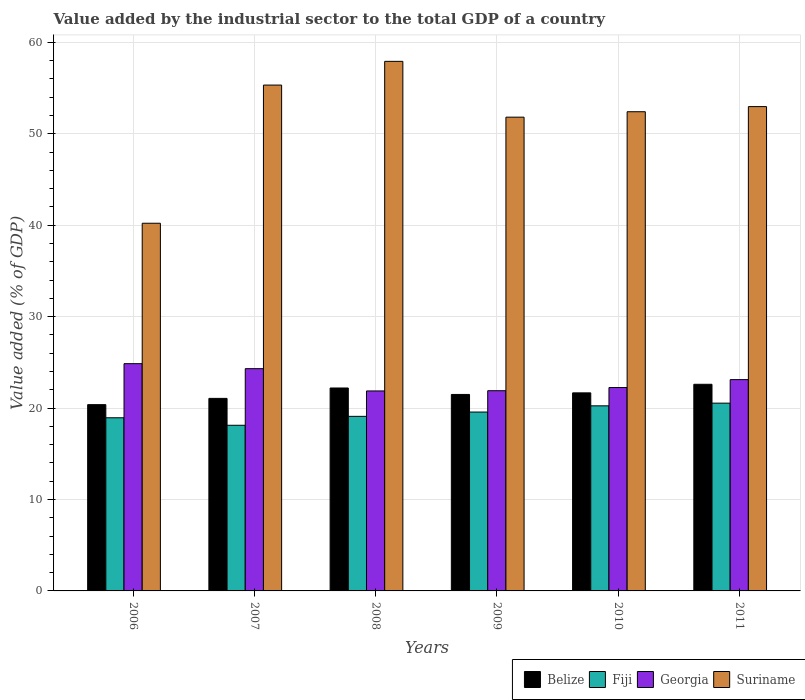How many different coloured bars are there?
Provide a short and direct response. 4. How many groups of bars are there?
Your answer should be compact. 6. Are the number of bars on each tick of the X-axis equal?
Provide a succinct answer. Yes. What is the label of the 6th group of bars from the left?
Provide a short and direct response. 2011. What is the value added by the industrial sector to the total GDP in Belize in 2010?
Provide a short and direct response. 21.66. Across all years, what is the maximum value added by the industrial sector to the total GDP in Georgia?
Provide a short and direct response. 24.86. Across all years, what is the minimum value added by the industrial sector to the total GDP in Belize?
Your answer should be compact. 20.37. In which year was the value added by the industrial sector to the total GDP in Georgia minimum?
Offer a terse response. 2008. What is the total value added by the industrial sector to the total GDP in Belize in the graph?
Provide a short and direct response. 129.38. What is the difference between the value added by the industrial sector to the total GDP in Belize in 2009 and that in 2011?
Provide a succinct answer. -1.11. What is the difference between the value added by the industrial sector to the total GDP in Belize in 2007 and the value added by the industrial sector to the total GDP in Fiji in 2006?
Provide a succinct answer. 2.12. What is the average value added by the industrial sector to the total GDP in Suriname per year?
Provide a short and direct response. 51.78. In the year 2008, what is the difference between the value added by the industrial sector to the total GDP in Suriname and value added by the industrial sector to the total GDP in Belize?
Offer a terse response. 35.72. What is the ratio of the value added by the industrial sector to the total GDP in Georgia in 2006 to that in 2009?
Provide a short and direct response. 1.14. Is the value added by the industrial sector to the total GDP in Belize in 2008 less than that in 2011?
Your answer should be very brief. Yes. What is the difference between the highest and the second highest value added by the industrial sector to the total GDP in Fiji?
Offer a very short reply. 0.29. What is the difference between the highest and the lowest value added by the industrial sector to the total GDP in Fiji?
Offer a very short reply. 2.42. In how many years, is the value added by the industrial sector to the total GDP in Georgia greater than the average value added by the industrial sector to the total GDP in Georgia taken over all years?
Ensure brevity in your answer.  3. What does the 1st bar from the left in 2010 represents?
Ensure brevity in your answer.  Belize. What does the 4th bar from the right in 2007 represents?
Provide a short and direct response. Belize. Is it the case that in every year, the sum of the value added by the industrial sector to the total GDP in Georgia and value added by the industrial sector to the total GDP in Fiji is greater than the value added by the industrial sector to the total GDP in Belize?
Offer a very short reply. Yes. Are all the bars in the graph horizontal?
Provide a succinct answer. No. What is the difference between two consecutive major ticks on the Y-axis?
Your response must be concise. 10. Are the values on the major ticks of Y-axis written in scientific E-notation?
Provide a short and direct response. No. Does the graph contain any zero values?
Provide a short and direct response. No. Does the graph contain grids?
Keep it short and to the point. Yes. Where does the legend appear in the graph?
Provide a succinct answer. Bottom right. How many legend labels are there?
Your answer should be very brief. 4. What is the title of the graph?
Provide a succinct answer. Value added by the industrial sector to the total GDP of a country. Does "Liechtenstein" appear as one of the legend labels in the graph?
Give a very brief answer. No. What is the label or title of the Y-axis?
Offer a terse response. Value added (% of GDP). What is the Value added (% of GDP) in Belize in 2006?
Provide a succinct answer. 20.37. What is the Value added (% of GDP) in Fiji in 2006?
Keep it short and to the point. 18.94. What is the Value added (% of GDP) in Georgia in 2006?
Provide a succinct answer. 24.86. What is the Value added (% of GDP) of Suriname in 2006?
Keep it short and to the point. 40.21. What is the Value added (% of GDP) of Belize in 2007?
Provide a succinct answer. 21.06. What is the Value added (% of GDP) in Fiji in 2007?
Give a very brief answer. 18.12. What is the Value added (% of GDP) of Georgia in 2007?
Offer a terse response. 24.31. What is the Value added (% of GDP) in Suriname in 2007?
Your response must be concise. 55.33. What is the Value added (% of GDP) in Belize in 2008?
Provide a succinct answer. 22.19. What is the Value added (% of GDP) in Fiji in 2008?
Offer a very short reply. 19.09. What is the Value added (% of GDP) in Georgia in 2008?
Make the answer very short. 21.87. What is the Value added (% of GDP) of Suriname in 2008?
Your response must be concise. 57.92. What is the Value added (% of GDP) in Belize in 2009?
Make the answer very short. 21.49. What is the Value added (% of GDP) in Fiji in 2009?
Provide a short and direct response. 19.56. What is the Value added (% of GDP) of Georgia in 2009?
Your answer should be compact. 21.9. What is the Value added (% of GDP) of Suriname in 2009?
Offer a terse response. 51.82. What is the Value added (% of GDP) of Belize in 2010?
Your answer should be compact. 21.66. What is the Value added (% of GDP) of Fiji in 2010?
Offer a terse response. 20.24. What is the Value added (% of GDP) in Georgia in 2010?
Give a very brief answer. 22.24. What is the Value added (% of GDP) in Suriname in 2010?
Make the answer very short. 52.41. What is the Value added (% of GDP) of Belize in 2011?
Provide a short and direct response. 22.6. What is the Value added (% of GDP) of Fiji in 2011?
Your answer should be compact. 20.54. What is the Value added (% of GDP) of Georgia in 2011?
Offer a very short reply. 23.11. What is the Value added (% of GDP) in Suriname in 2011?
Keep it short and to the point. 52.97. Across all years, what is the maximum Value added (% of GDP) in Belize?
Make the answer very short. 22.6. Across all years, what is the maximum Value added (% of GDP) in Fiji?
Offer a very short reply. 20.54. Across all years, what is the maximum Value added (% of GDP) in Georgia?
Your answer should be compact. 24.86. Across all years, what is the maximum Value added (% of GDP) of Suriname?
Make the answer very short. 57.92. Across all years, what is the minimum Value added (% of GDP) in Belize?
Provide a succinct answer. 20.37. Across all years, what is the minimum Value added (% of GDP) in Fiji?
Make the answer very short. 18.12. Across all years, what is the minimum Value added (% of GDP) of Georgia?
Your answer should be compact. 21.87. Across all years, what is the minimum Value added (% of GDP) in Suriname?
Ensure brevity in your answer.  40.21. What is the total Value added (% of GDP) in Belize in the graph?
Make the answer very short. 129.38. What is the total Value added (% of GDP) in Fiji in the graph?
Your answer should be very brief. 116.49. What is the total Value added (% of GDP) in Georgia in the graph?
Offer a terse response. 138.29. What is the total Value added (% of GDP) in Suriname in the graph?
Provide a short and direct response. 310.65. What is the difference between the Value added (% of GDP) in Belize in 2006 and that in 2007?
Offer a terse response. -0.69. What is the difference between the Value added (% of GDP) of Fiji in 2006 and that in 2007?
Keep it short and to the point. 0.82. What is the difference between the Value added (% of GDP) in Georgia in 2006 and that in 2007?
Provide a short and direct response. 0.55. What is the difference between the Value added (% of GDP) in Suriname in 2006 and that in 2007?
Provide a succinct answer. -15.11. What is the difference between the Value added (% of GDP) of Belize in 2006 and that in 2008?
Provide a short and direct response. -1.82. What is the difference between the Value added (% of GDP) in Fiji in 2006 and that in 2008?
Provide a short and direct response. -0.15. What is the difference between the Value added (% of GDP) in Georgia in 2006 and that in 2008?
Ensure brevity in your answer.  2.98. What is the difference between the Value added (% of GDP) in Suriname in 2006 and that in 2008?
Your response must be concise. -17.71. What is the difference between the Value added (% of GDP) in Belize in 2006 and that in 2009?
Your response must be concise. -1.12. What is the difference between the Value added (% of GDP) of Fiji in 2006 and that in 2009?
Offer a very short reply. -0.63. What is the difference between the Value added (% of GDP) of Georgia in 2006 and that in 2009?
Keep it short and to the point. 2.96. What is the difference between the Value added (% of GDP) of Suriname in 2006 and that in 2009?
Offer a very short reply. -11.6. What is the difference between the Value added (% of GDP) in Belize in 2006 and that in 2010?
Make the answer very short. -1.29. What is the difference between the Value added (% of GDP) of Fiji in 2006 and that in 2010?
Ensure brevity in your answer.  -1.31. What is the difference between the Value added (% of GDP) in Georgia in 2006 and that in 2010?
Provide a short and direct response. 2.61. What is the difference between the Value added (% of GDP) in Suriname in 2006 and that in 2010?
Provide a succinct answer. -12.2. What is the difference between the Value added (% of GDP) of Belize in 2006 and that in 2011?
Offer a terse response. -2.23. What is the difference between the Value added (% of GDP) of Fiji in 2006 and that in 2011?
Offer a terse response. -1.6. What is the difference between the Value added (% of GDP) in Georgia in 2006 and that in 2011?
Offer a very short reply. 1.75. What is the difference between the Value added (% of GDP) of Suriname in 2006 and that in 2011?
Your answer should be very brief. -12.76. What is the difference between the Value added (% of GDP) in Belize in 2007 and that in 2008?
Provide a succinct answer. -1.14. What is the difference between the Value added (% of GDP) in Fiji in 2007 and that in 2008?
Provide a succinct answer. -0.98. What is the difference between the Value added (% of GDP) of Georgia in 2007 and that in 2008?
Offer a terse response. 2.44. What is the difference between the Value added (% of GDP) of Suriname in 2007 and that in 2008?
Provide a succinct answer. -2.59. What is the difference between the Value added (% of GDP) of Belize in 2007 and that in 2009?
Offer a very short reply. -0.43. What is the difference between the Value added (% of GDP) in Fiji in 2007 and that in 2009?
Provide a short and direct response. -1.45. What is the difference between the Value added (% of GDP) in Georgia in 2007 and that in 2009?
Ensure brevity in your answer.  2.41. What is the difference between the Value added (% of GDP) of Suriname in 2007 and that in 2009?
Your answer should be very brief. 3.51. What is the difference between the Value added (% of GDP) in Belize in 2007 and that in 2010?
Ensure brevity in your answer.  -0.6. What is the difference between the Value added (% of GDP) of Fiji in 2007 and that in 2010?
Ensure brevity in your answer.  -2.13. What is the difference between the Value added (% of GDP) in Georgia in 2007 and that in 2010?
Your response must be concise. 2.07. What is the difference between the Value added (% of GDP) in Suriname in 2007 and that in 2010?
Your response must be concise. 2.92. What is the difference between the Value added (% of GDP) of Belize in 2007 and that in 2011?
Offer a terse response. -1.54. What is the difference between the Value added (% of GDP) in Fiji in 2007 and that in 2011?
Your response must be concise. -2.42. What is the difference between the Value added (% of GDP) in Georgia in 2007 and that in 2011?
Give a very brief answer. 1.2. What is the difference between the Value added (% of GDP) of Suriname in 2007 and that in 2011?
Your response must be concise. 2.36. What is the difference between the Value added (% of GDP) in Belize in 2008 and that in 2009?
Your response must be concise. 0.71. What is the difference between the Value added (% of GDP) in Fiji in 2008 and that in 2009?
Your response must be concise. -0.47. What is the difference between the Value added (% of GDP) of Georgia in 2008 and that in 2009?
Provide a succinct answer. -0.03. What is the difference between the Value added (% of GDP) of Suriname in 2008 and that in 2009?
Provide a succinct answer. 6.1. What is the difference between the Value added (% of GDP) in Belize in 2008 and that in 2010?
Give a very brief answer. 0.53. What is the difference between the Value added (% of GDP) of Fiji in 2008 and that in 2010?
Make the answer very short. -1.15. What is the difference between the Value added (% of GDP) of Georgia in 2008 and that in 2010?
Your response must be concise. -0.37. What is the difference between the Value added (% of GDP) in Suriname in 2008 and that in 2010?
Your answer should be compact. 5.51. What is the difference between the Value added (% of GDP) of Belize in 2008 and that in 2011?
Offer a terse response. -0.41. What is the difference between the Value added (% of GDP) of Fiji in 2008 and that in 2011?
Make the answer very short. -1.44. What is the difference between the Value added (% of GDP) in Georgia in 2008 and that in 2011?
Offer a terse response. -1.24. What is the difference between the Value added (% of GDP) in Suriname in 2008 and that in 2011?
Make the answer very short. 4.95. What is the difference between the Value added (% of GDP) in Belize in 2009 and that in 2010?
Your response must be concise. -0.17. What is the difference between the Value added (% of GDP) in Fiji in 2009 and that in 2010?
Offer a very short reply. -0.68. What is the difference between the Value added (% of GDP) in Georgia in 2009 and that in 2010?
Keep it short and to the point. -0.35. What is the difference between the Value added (% of GDP) of Suriname in 2009 and that in 2010?
Provide a short and direct response. -0.59. What is the difference between the Value added (% of GDP) of Belize in 2009 and that in 2011?
Your response must be concise. -1.11. What is the difference between the Value added (% of GDP) in Fiji in 2009 and that in 2011?
Make the answer very short. -0.97. What is the difference between the Value added (% of GDP) in Georgia in 2009 and that in 2011?
Ensure brevity in your answer.  -1.21. What is the difference between the Value added (% of GDP) in Suriname in 2009 and that in 2011?
Ensure brevity in your answer.  -1.15. What is the difference between the Value added (% of GDP) in Belize in 2010 and that in 2011?
Make the answer very short. -0.94. What is the difference between the Value added (% of GDP) of Fiji in 2010 and that in 2011?
Provide a short and direct response. -0.29. What is the difference between the Value added (% of GDP) of Georgia in 2010 and that in 2011?
Give a very brief answer. -0.87. What is the difference between the Value added (% of GDP) in Suriname in 2010 and that in 2011?
Your answer should be very brief. -0.56. What is the difference between the Value added (% of GDP) in Belize in 2006 and the Value added (% of GDP) in Fiji in 2007?
Your response must be concise. 2.26. What is the difference between the Value added (% of GDP) of Belize in 2006 and the Value added (% of GDP) of Georgia in 2007?
Give a very brief answer. -3.94. What is the difference between the Value added (% of GDP) in Belize in 2006 and the Value added (% of GDP) in Suriname in 2007?
Your response must be concise. -34.95. What is the difference between the Value added (% of GDP) in Fiji in 2006 and the Value added (% of GDP) in Georgia in 2007?
Provide a short and direct response. -5.37. What is the difference between the Value added (% of GDP) of Fiji in 2006 and the Value added (% of GDP) of Suriname in 2007?
Offer a terse response. -36.39. What is the difference between the Value added (% of GDP) of Georgia in 2006 and the Value added (% of GDP) of Suriname in 2007?
Your response must be concise. -30.47. What is the difference between the Value added (% of GDP) in Belize in 2006 and the Value added (% of GDP) in Fiji in 2008?
Provide a succinct answer. 1.28. What is the difference between the Value added (% of GDP) in Belize in 2006 and the Value added (% of GDP) in Georgia in 2008?
Your answer should be compact. -1.5. What is the difference between the Value added (% of GDP) of Belize in 2006 and the Value added (% of GDP) of Suriname in 2008?
Give a very brief answer. -37.55. What is the difference between the Value added (% of GDP) in Fiji in 2006 and the Value added (% of GDP) in Georgia in 2008?
Your answer should be compact. -2.93. What is the difference between the Value added (% of GDP) in Fiji in 2006 and the Value added (% of GDP) in Suriname in 2008?
Make the answer very short. -38.98. What is the difference between the Value added (% of GDP) in Georgia in 2006 and the Value added (% of GDP) in Suriname in 2008?
Give a very brief answer. -33.06. What is the difference between the Value added (% of GDP) of Belize in 2006 and the Value added (% of GDP) of Fiji in 2009?
Keep it short and to the point. 0.81. What is the difference between the Value added (% of GDP) in Belize in 2006 and the Value added (% of GDP) in Georgia in 2009?
Offer a very short reply. -1.52. What is the difference between the Value added (% of GDP) in Belize in 2006 and the Value added (% of GDP) in Suriname in 2009?
Your answer should be very brief. -31.44. What is the difference between the Value added (% of GDP) of Fiji in 2006 and the Value added (% of GDP) of Georgia in 2009?
Your answer should be very brief. -2.96. What is the difference between the Value added (% of GDP) in Fiji in 2006 and the Value added (% of GDP) in Suriname in 2009?
Give a very brief answer. -32.88. What is the difference between the Value added (% of GDP) in Georgia in 2006 and the Value added (% of GDP) in Suriname in 2009?
Your response must be concise. -26.96. What is the difference between the Value added (% of GDP) in Belize in 2006 and the Value added (% of GDP) in Fiji in 2010?
Your answer should be compact. 0.13. What is the difference between the Value added (% of GDP) of Belize in 2006 and the Value added (% of GDP) of Georgia in 2010?
Your answer should be very brief. -1.87. What is the difference between the Value added (% of GDP) in Belize in 2006 and the Value added (% of GDP) in Suriname in 2010?
Provide a short and direct response. -32.04. What is the difference between the Value added (% of GDP) in Fiji in 2006 and the Value added (% of GDP) in Georgia in 2010?
Provide a succinct answer. -3.3. What is the difference between the Value added (% of GDP) of Fiji in 2006 and the Value added (% of GDP) of Suriname in 2010?
Make the answer very short. -33.47. What is the difference between the Value added (% of GDP) of Georgia in 2006 and the Value added (% of GDP) of Suriname in 2010?
Your answer should be compact. -27.55. What is the difference between the Value added (% of GDP) of Belize in 2006 and the Value added (% of GDP) of Fiji in 2011?
Ensure brevity in your answer.  -0.16. What is the difference between the Value added (% of GDP) in Belize in 2006 and the Value added (% of GDP) in Georgia in 2011?
Give a very brief answer. -2.74. What is the difference between the Value added (% of GDP) in Belize in 2006 and the Value added (% of GDP) in Suriname in 2011?
Your answer should be compact. -32.6. What is the difference between the Value added (% of GDP) in Fiji in 2006 and the Value added (% of GDP) in Georgia in 2011?
Your answer should be very brief. -4.17. What is the difference between the Value added (% of GDP) in Fiji in 2006 and the Value added (% of GDP) in Suriname in 2011?
Give a very brief answer. -34.03. What is the difference between the Value added (% of GDP) in Georgia in 2006 and the Value added (% of GDP) in Suriname in 2011?
Provide a short and direct response. -28.11. What is the difference between the Value added (% of GDP) of Belize in 2007 and the Value added (% of GDP) of Fiji in 2008?
Offer a very short reply. 1.97. What is the difference between the Value added (% of GDP) in Belize in 2007 and the Value added (% of GDP) in Georgia in 2008?
Make the answer very short. -0.81. What is the difference between the Value added (% of GDP) in Belize in 2007 and the Value added (% of GDP) in Suriname in 2008?
Your answer should be compact. -36.86. What is the difference between the Value added (% of GDP) in Fiji in 2007 and the Value added (% of GDP) in Georgia in 2008?
Your answer should be compact. -3.75. What is the difference between the Value added (% of GDP) of Fiji in 2007 and the Value added (% of GDP) of Suriname in 2008?
Offer a terse response. -39.8. What is the difference between the Value added (% of GDP) in Georgia in 2007 and the Value added (% of GDP) in Suriname in 2008?
Ensure brevity in your answer.  -33.61. What is the difference between the Value added (% of GDP) in Belize in 2007 and the Value added (% of GDP) in Fiji in 2009?
Give a very brief answer. 1.5. What is the difference between the Value added (% of GDP) in Belize in 2007 and the Value added (% of GDP) in Georgia in 2009?
Your answer should be very brief. -0.84. What is the difference between the Value added (% of GDP) in Belize in 2007 and the Value added (% of GDP) in Suriname in 2009?
Offer a very short reply. -30.76. What is the difference between the Value added (% of GDP) in Fiji in 2007 and the Value added (% of GDP) in Georgia in 2009?
Provide a succinct answer. -3.78. What is the difference between the Value added (% of GDP) in Fiji in 2007 and the Value added (% of GDP) in Suriname in 2009?
Make the answer very short. -33.7. What is the difference between the Value added (% of GDP) of Georgia in 2007 and the Value added (% of GDP) of Suriname in 2009?
Offer a very short reply. -27.51. What is the difference between the Value added (% of GDP) of Belize in 2007 and the Value added (% of GDP) of Fiji in 2010?
Provide a short and direct response. 0.82. What is the difference between the Value added (% of GDP) in Belize in 2007 and the Value added (% of GDP) in Georgia in 2010?
Make the answer very short. -1.18. What is the difference between the Value added (% of GDP) in Belize in 2007 and the Value added (% of GDP) in Suriname in 2010?
Your response must be concise. -31.35. What is the difference between the Value added (% of GDP) of Fiji in 2007 and the Value added (% of GDP) of Georgia in 2010?
Your answer should be compact. -4.13. What is the difference between the Value added (% of GDP) of Fiji in 2007 and the Value added (% of GDP) of Suriname in 2010?
Make the answer very short. -34.29. What is the difference between the Value added (% of GDP) in Georgia in 2007 and the Value added (% of GDP) in Suriname in 2010?
Offer a very short reply. -28.1. What is the difference between the Value added (% of GDP) of Belize in 2007 and the Value added (% of GDP) of Fiji in 2011?
Offer a terse response. 0.52. What is the difference between the Value added (% of GDP) of Belize in 2007 and the Value added (% of GDP) of Georgia in 2011?
Make the answer very short. -2.05. What is the difference between the Value added (% of GDP) in Belize in 2007 and the Value added (% of GDP) in Suriname in 2011?
Make the answer very short. -31.91. What is the difference between the Value added (% of GDP) of Fiji in 2007 and the Value added (% of GDP) of Georgia in 2011?
Make the answer very short. -4.99. What is the difference between the Value added (% of GDP) in Fiji in 2007 and the Value added (% of GDP) in Suriname in 2011?
Your response must be concise. -34.85. What is the difference between the Value added (% of GDP) of Georgia in 2007 and the Value added (% of GDP) of Suriname in 2011?
Your response must be concise. -28.66. What is the difference between the Value added (% of GDP) in Belize in 2008 and the Value added (% of GDP) in Fiji in 2009?
Your answer should be very brief. 2.63. What is the difference between the Value added (% of GDP) of Belize in 2008 and the Value added (% of GDP) of Georgia in 2009?
Your response must be concise. 0.3. What is the difference between the Value added (% of GDP) in Belize in 2008 and the Value added (% of GDP) in Suriname in 2009?
Give a very brief answer. -29.62. What is the difference between the Value added (% of GDP) in Fiji in 2008 and the Value added (% of GDP) in Georgia in 2009?
Your answer should be compact. -2.8. What is the difference between the Value added (% of GDP) in Fiji in 2008 and the Value added (% of GDP) in Suriname in 2009?
Your response must be concise. -32.72. What is the difference between the Value added (% of GDP) in Georgia in 2008 and the Value added (% of GDP) in Suriname in 2009?
Your response must be concise. -29.94. What is the difference between the Value added (% of GDP) of Belize in 2008 and the Value added (% of GDP) of Fiji in 2010?
Your answer should be compact. 1.95. What is the difference between the Value added (% of GDP) of Belize in 2008 and the Value added (% of GDP) of Georgia in 2010?
Your answer should be compact. -0.05. What is the difference between the Value added (% of GDP) of Belize in 2008 and the Value added (% of GDP) of Suriname in 2010?
Keep it short and to the point. -30.22. What is the difference between the Value added (% of GDP) of Fiji in 2008 and the Value added (% of GDP) of Georgia in 2010?
Offer a very short reply. -3.15. What is the difference between the Value added (% of GDP) of Fiji in 2008 and the Value added (% of GDP) of Suriname in 2010?
Your response must be concise. -33.32. What is the difference between the Value added (% of GDP) of Georgia in 2008 and the Value added (% of GDP) of Suriname in 2010?
Give a very brief answer. -30.54. What is the difference between the Value added (% of GDP) in Belize in 2008 and the Value added (% of GDP) in Fiji in 2011?
Keep it short and to the point. 1.66. What is the difference between the Value added (% of GDP) in Belize in 2008 and the Value added (% of GDP) in Georgia in 2011?
Offer a terse response. -0.92. What is the difference between the Value added (% of GDP) of Belize in 2008 and the Value added (% of GDP) of Suriname in 2011?
Offer a terse response. -30.78. What is the difference between the Value added (% of GDP) of Fiji in 2008 and the Value added (% of GDP) of Georgia in 2011?
Your answer should be compact. -4.02. What is the difference between the Value added (% of GDP) of Fiji in 2008 and the Value added (% of GDP) of Suriname in 2011?
Provide a succinct answer. -33.88. What is the difference between the Value added (% of GDP) in Georgia in 2008 and the Value added (% of GDP) in Suriname in 2011?
Your response must be concise. -31.1. What is the difference between the Value added (% of GDP) in Belize in 2009 and the Value added (% of GDP) in Fiji in 2010?
Keep it short and to the point. 1.25. What is the difference between the Value added (% of GDP) in Belize in 2009 and the Value added (% of GDP) in Georgia in 2010?
Keep it short and to the point. -0.75. What is the difference between the Value added (% of GDP) of Belize in 2009 and the Value added (% of GDP) of Suriname in 2010?
Keep it short and to the point. -30.92. What is the difference between the Value added (% of GDP) of Fiji in 2009 and the Value added (% of GDP) of Georgia in 2010?
Offer a very short reply. -2.68. What is the difference between the Value added (% of GDP) of Fiji in 2009 and the Value added (% of GDP) of Suriname in 2010?
Provide a short and direct response. -32.85. What is the difference between the Value added (% of GDP) of Georgia in 2009 and the Value added (% of GDP) of Suriname in 2010?
Provide a succinct answer. -30.51. What is the difference between the Value added (% of GDP) in Belize in 2009 and the Value added (% of GDP) in Fiji in 2011?
Provide a succinct answer. 0.95. What is the difference between the Value added (% of GDP) of Belize in 2009 and the Value added (% of GDP) of Georgia in 2011?
Provide a short and direct response. -1.62. What is the difference between the Value added (% of GDP) of Belize in 2009 and the Value added (% of GDP) of Suriname in 2011?
Provide a short and direct response. -31.48. What is the difference between the Value added (% of GDP) of Fiji in 2009 and the Value added (% of GDP) of Georgia in 2011?
Provide a short and direct response. -3.55. What is the difference between the Value added (% of GDP) in Fiji in 2009 and the Value added (% of GDP) in Suriname in 2011?
Make the answer very short. -33.41. What is the difference between the Value added (% of GDP) of Georgia in 2009 and the Value added (% of GDP) of Suriname in 2011?
Your answer should be compact. -31.07. What is the difference between the Value added (% of GDP) of Belize in 2010 and the Value added (% of GDP) of Fiji in 2011?
Provide a succinct answer. 1.12. What is the difference between the Value added (% of GDP) of Belize in 2010 and the Value added (% of GDP) of Georgia in 2011?
Your response must be concise. -1.45. What is the difference between the Value added (% of GDP) of Belize in 2010 and the Value added (% of GDP) of Suriname in 2011?
Your answer should be compact. -31.31. What is the difference between the Value added (% of GDP) of Fiji in 2010 and the Value added (% of GDP) of Georgia in 2011?
Your answer should be very brief. -2.87. What is the difference between the Value added (% of GDP) in Fiji in 2010 and the Value added (% of GDP) in Suriname in 2011?
Make the answer very short. -32.73. What is the difference between the Value added (% of GDP) in Georgia in 2010 and the Value added (% of GDP) in Suriname in 2011?
Your response must be concise. -30.73. What is the average Value added (% of GDP) in Belize per year?
Offer a very short reply. 21.56. What is the average Value added (% of GDP) of Fiji per year?
Offer a very short reply. 19.42. What is the average Value added (% of GDP) of Georgia per year?
Give a very brief answer. 23.05. What is the average Value added (% of GDP) of Suriname per year?
Your answer should be very brief. 51.78. In the year 2006, what is the difference between the Value added (% of GDP) in Belize and Value added (% of GDP) in Fiji?
Provide a succinct answer. 1.44. In the year 2006, what is the difference between the Value added (% of GDP) of Belize and Value added (% of GDP) of Georgia?
Your answer should be compact. -4.48. In the year 2006, what is the difference between the Value added (% of GDP) in Belize and Value added (% of GDP) in Suriname?
Keep it short and to the point. -19.84. In the year 2006, what is the difference between the Value added (% of GDP) of Fiji and Value added (% of GDP) of Georgia?
Provide a short and direct response. -5.92. In the year 2006, what is the difference between the Value added (% of GDP) of Fiji and Value added (% of GDP) of Suriname?
Keep it short and to the point. -21.28. In the year 2006, what is the difference between the Value added (% of GDP) of Georgia and Value added (% of GDP) of Suriname?
Your answer should be compact. -15.36. In the year 2007, what is the difference between the Value added (% of GDP) in Belize and Value added (% of GDP) in Fiji?
Provide a succinct answer. 2.94. In the year 2007, what is the difference between the Value added (% of GDP) in Belize and Value added (% of GDP) in Georgia?
Offer a very short reply. -3.25. In the year 2007, what is the difference between the Value added (% of GDP) in Belize and Value added (% of GDP) in Suriname?
Ensure brevity in your answer.  -34.27. In the year 2007, what is the difference between the Value added (% of GDP) of Fiji and Value added (% of GDP) of Georgia?
Provide a short and direct response. -6.19. In the year 2007, what is the difference between the Value added (% of GDP) in Fiji and Value added (% of GDP) in Suriname?
Keep it short and to the point. -37.21. In the year 2007, what is the difference between the Value added (% of GDP) in Georgia and Value added (% of GDP) in Suriname?
Provide a succinct answer. -31.02. In the year 2008, what is the difference between the Value added (% of GDP) in Belize and Value added (% of GDP) in Fiji?
Provide a succinct answer. 3.1. In the year 2008, what is the difference between the Value added (% of GDP) of Belize and Value added (% of GDP) of Georgia?
Ensure brevity in your answer.  0.32. In the year 2008, what is the difference between the Value added (% of GDP) of Belize and Value added (% of GDP) of Suriname?
Provide a short and direct response. -35.72. In the year 2008, what is the difference between the Value added (% of GDP) in Fiji and Value added (% of GDP) in Georgia?
Offer a very short reply. -2.78. In the year 2008, what is the difference between the Value added (% of GDP) of Fiji and Value added (% of GDP) of Suriname?
Keep it short and to the point. -38.83. In the year 2008, what is the difference between the Value added (% of GDP) in Georgia and Value added (% of GDP) in Suriname?
Keep it short and to the point. -36.05. In the year 2009, what is the difference between the Value added (% of GDP) in Belize and Value added (% of GDP) in Fiji?
Make the answer very short. 1.93. In the year 2009, what is the difference between the Value added (% of GDP) of Belize and Value added (% of GDP) of Georgia?
Keep it short and to the point. -0.41. In the year 2009, what is the difference between the Value added (% of GDP) of Belize and Value added (% of GDP) of Suriname?
Ensure brevity in your answer.  -30.33. In the year 2009, what is the difference between the Value added (% of GDP) in Fiji and Value added (% of GDP) in Georgia?
Offer a terse response. -2.33. In the year 2009, what is the difference between the Value added (% of GDP) in Fiji and Value added (% of GDP) in Suriname?
Offer a terse response. -32.25. In the year 2009, what is the difference between the Value added (% of GDP) in Georgia and Value added (% of GDP) in Suriname?
Provide a succinct answer. -29.92. In the year 2010, what is the difference between the Value added (% of GDP) in Belize and Value added (% of GDP) in Fiji?
Make the answer very short. 1.42. In the year 2010, what is the difference between the Value added (% of GDP) of Belize and Value added (% of GDP) of Georgia?
Provide a succinct answer. -0.58. In the year 2010, what is the difference between the Value added (% of GDP) in Belize and Value added (% of GDP) in Suriname?
Ensure brevity in your answer.  -30.75. In the year 2010, what is the difference between the Value added (% of GDP) in Fiji and Value added (% of GDP) in Georgia?
Offer a very short reply. -2. In the year 2010, what is the difference between the Value added (% of GDP) of Fiji and Value added (% of GDP) of Suriname?
Provide a succinct answer. -32.17. In the year 2010, what is the difference between the Value added (% of GDP) of Georgia and Value added (% of GDP) of Suriname?
Your answer should be very brief. -30.17. In the year 2011, what is the difference between the Value added (% of GDP) in Belize and Value added (% of GDP) in Fiji?
Offer a very short reply. 2.06. In the year 2011, what is the difference between the Value added (% of GDP) of Belize and Value added (% of GDP) of Georgia?
Give a very brief answer. -0.51. In the year 2011, what is the difference between the Value added (% of GDP) in Belize and Value added (% of GDP) in Suriname?
Your response must be concise. -30.37. In the year 2011, what is the difference between the Value added (% of GDP) of Fiji and Value added (% of GDP) of Georgia?
Provide a short and direct response. -2.57. In the year 2011, what is the difference between the Value added (% of GDP) of Fiji and Value added (% of GDP) of Suriname?
Make the answer very short. -32.43. In the year 2011, what is the difference between the Value added (% of GDP) in Georgia and Value added (% of GDP) in Suriname?
Your answer should be very brief. -29.86. What is the ratio of the Value added (% of GDP) in Belize in 2006 to that in 2007?
Your response must be concise. 0.97. What is the ratio of the Value added (% of GDP) of Fiji in 2006 to that in 2007?
Keep it short and to the point. 1.05. What is the ratio of the Value added (% of GDP) of Georgia in 2006 to that in 2007?
Make the answer very short. 1.02. What is the ratio of the Value added (% of GDP) of Suriname in 2006 to that in 2007?
Give a very brief answer. 0.73. What is the ratio of the Value added (% of GDP) in Belize in 2006 to that in 2008?
Your answer should be very brief. 0.92. What is the ratio of the Value added (% of GDP) in Georgia in 2006 to that in 2008?
Your answer should be compact. 1.14. What is the ratio of the Value added (% of GDP) in Suriname in 2006 to that in 2008?
Your response must be concise. 0.69. What is the ratio of the Value added (% of GDP) in Belize in 2006 to that in 2009?
Offer a very short reply. 0.95. What is the ratio of the Value added (% of GDP) in Georgia in 2006 to that in 2009?
Your response must be concise. 1.14. What is the ratio of the Value added (% of GDP) of Suriname in 2006 to that in 2009?
Keep it short and to the point. 0.78. What is the ratio of the Value added (% of GDP) of Belize in 2006 to that in 2010?
Give a very brief answer. 0.94. What is the ratio of the Value added (% of GDP) of Fiji in 2006 to that in 2010?
Your answer should be very brief. 0.94. What is the ratio of the Value added (% of GDP) in Georgia in 2006 to that in 2010?
Give a very brief answer. 1.12. What is the ratio of the Value added (% of GDP) in Suriname in 2006 to that in 2010?
Provide a short and direct response. 0.77. What is the ratio of the Value added (% of GDP) in Belize in 2006 to that in 2011?
Make the answer very short. 0.9. What is the ratio of the Value added (% of GDP) of Fiji in 2006 to that in 2011?
Keep it short and to the point. 0.92. What is the ratio of the Value added (% of GDP) in Georgia in 2006 to that in 2011?
Give a very brief answer. 1.08. What is the ratio of the Value added (% of GDP) in Suriname in 2006 to that in 2011?
Your answer should be very brief. 0.76. What is the ratio of the Value added (% of GDP) in Belize in 2007 to that in 2008?
Ensure brevity in your answer.  0.95. What is the ratio of the Value added (% of GDP) in Fiji in 2007 to that in 2008?
Your answer should be compact. 0.95. What is the ratio of the Value added (% of GDP) of Georgia in 2007 to that in 2008?
Offer a very short reply. 1.11. What is the ratio of the Value added (% of GDP) of Suriname in 2007 to that in 2008?
Your answer should be compact. 0.96. What is the ratio of the Value added (% of GDP) in Fiji in 2007 to that in 2009?
Keep it short and to the point. 0.93. What is the ratio of the Value added (% of GDP) of Georgia in 2007 to that in 2009?
Give a very brief answer. 1.11. What is the ratio of the Value added (% of GDP) of Suriname in 2007 to that in 2009?
Ensure brevity in your answer.  1.07. What is the ratio of the Value added (% of GDP) of Belize in 2007 to that in 2010?
Offer a very short reply. 0.97. What is the ratio of the Value added (% of GDP) of Fiji in 2007 to that in 2010?
Your response must be concise. 0.89. What is the ratio of the Value added (% of GDP) in Georgia in 2007 to that in 2010?
Ensure brevity in your answer.  1.09. What is the ratio of the Value added (% of GDP) of Suriname in 2007 to that in 2010?
Offer a terse response. 1.06. What is the ratio of the Value added (% of GDP) in Belize in 2007 to that in 2011?
Provide a short and direct response. 0.93. What is the ratio of the Value added (% of GDP) of Fiji in 2007 to that in 2011?
Make the answer very short. 0.88. What is the ratio of the Value added (% of GDP) in Georgia in 2007 to that in 2011?
Offer a very short reply. 1.05. What is the ratio of the Value added (% of GDP) in Suriname in 2007 to that in 2011?
Provide a short and direct response. 1.04. What is the ratio of the Value added (% of GDP) in Belize in 2008 to that in 2009?
Offer a terse response. 1.03. What is the ratio of the Value added (% of GDP) in Fiji in 2008 to that in 2009?
Give a very brief answer. 0.98. What is the ratio of the Value added (% of GDP) of Suriname in 2008 to that in 2009?
Provide a short and direct response. 1.12. What is the ratio of the Value added (% of GDP) of Belize in 2008 to that in 2010?
Give a very brief answer. 1.02. What is the ratio of the Value added (% of GDP) of Fiji in 2008 to that in 2010?
Provide a succinct answer. 0.94. What is the ratio of the Value added (% of GDP) of Georgia in 2008 to that in 2010?
Give a very brief answer. 0.98. What is the ratio of the Value added (% of GDP) of Suriname in 2008 to that in 2010?
Ensure brevity in your answer.  1.11. What is the ratio of the Value added (% of GDP) in Belize in 2008 to that in 2011?
Make the answer very short. 0.98. What is the ratio of the Value added (% of GDP) of Fiji in 2008 to that in 2011?
Your answer should be very brief. 0.93. What is the ratio of the Value added (% of GDP) in Georgia in 2008 to that in 2011?
Ensure brevity in your answer.  0.95. What is the ratio of the Value added (% of GDP) in Suriname in 2008 to that in 2011?
Your response must be concise. 1.09. What is the ratio of the Value added (% of GDP) of Belize in 2009 to that in 2010?
Provide a succinct answer. 0.99. What is the ratio of the Value added (% of GDP) of Fiji in 2009 to that in 2010?
Your answer should be very brief. 0.97. What is the ratio of the Value added (% of GDP) of Georgia in 2009 to that in 2010?
Keep it short and to the point. 0.98. What is the ratio of the Value added (% of GDP) in Suriname in 2009 to that in 2010?
Provide a succinct answer. 0.99. What is the ratio of the Value added (% of GDP) of Belize in 2009 to that in 2011?
Keep it short and to the point. 0.95. What is the ratio of the Value added (% of GDP) of Fiji in 2009 to that in 2011?
Give a very brief answer. 0.95. What is the ratio of the Value added (% of GDP) in Suriname in 2009 to that in 2011?
Offer a very short reply. 0.98. What is the ratio of the Value added (% of GDP) in Belize in 2010 to that in 2011?
Your answer should be compact. 0.96. What is the ratio of the Value added (% of GDP) in Fiji in 2010 to that in 2011?
Make the answer very short. 0.99. What is the ratio of the Value added (% of GDP) of Georgia in 2010 to that in 2011?
Keep it short and to the point. 0.96. What is the ratio of the Value added (% of GDP) in Suriname in 2010 to that in 2011?
Ensure brevity in your answer.  0.99. What is the difference between the highest and the second highest Value added (% of GDP) of Belize?
Offer a very short reply. 0.41. What is the difference between the highest and the second highest Value added (% of GDP) in Fiji?
Make the answer very short. 0.29. What is the difference between the highest and the second highest Value added (% of GDP) in Georgia?
Provide a short and direct response. 0.55. What is the difference between the highest and the second highest Value added (% of GDP) in Suriname?
Your answer should be very brief. 2.59. What is the difference between the highest and the lowest Value added (% of GDP) in Belize?
Provide a succinct answer. 2.23. What is the difference between the highest and the lowest Value added (% of GDP) of Fiji?
Give a very brief answer. 2.42. What is the difference between the highest and the lowest Value added (% of GDP) in Georgia?
Make the answer very short. 2.98. What is the difference between the highest and the lowest Value added (% of GDP) in Suriname?
Offer a very short reply. 17.71. 